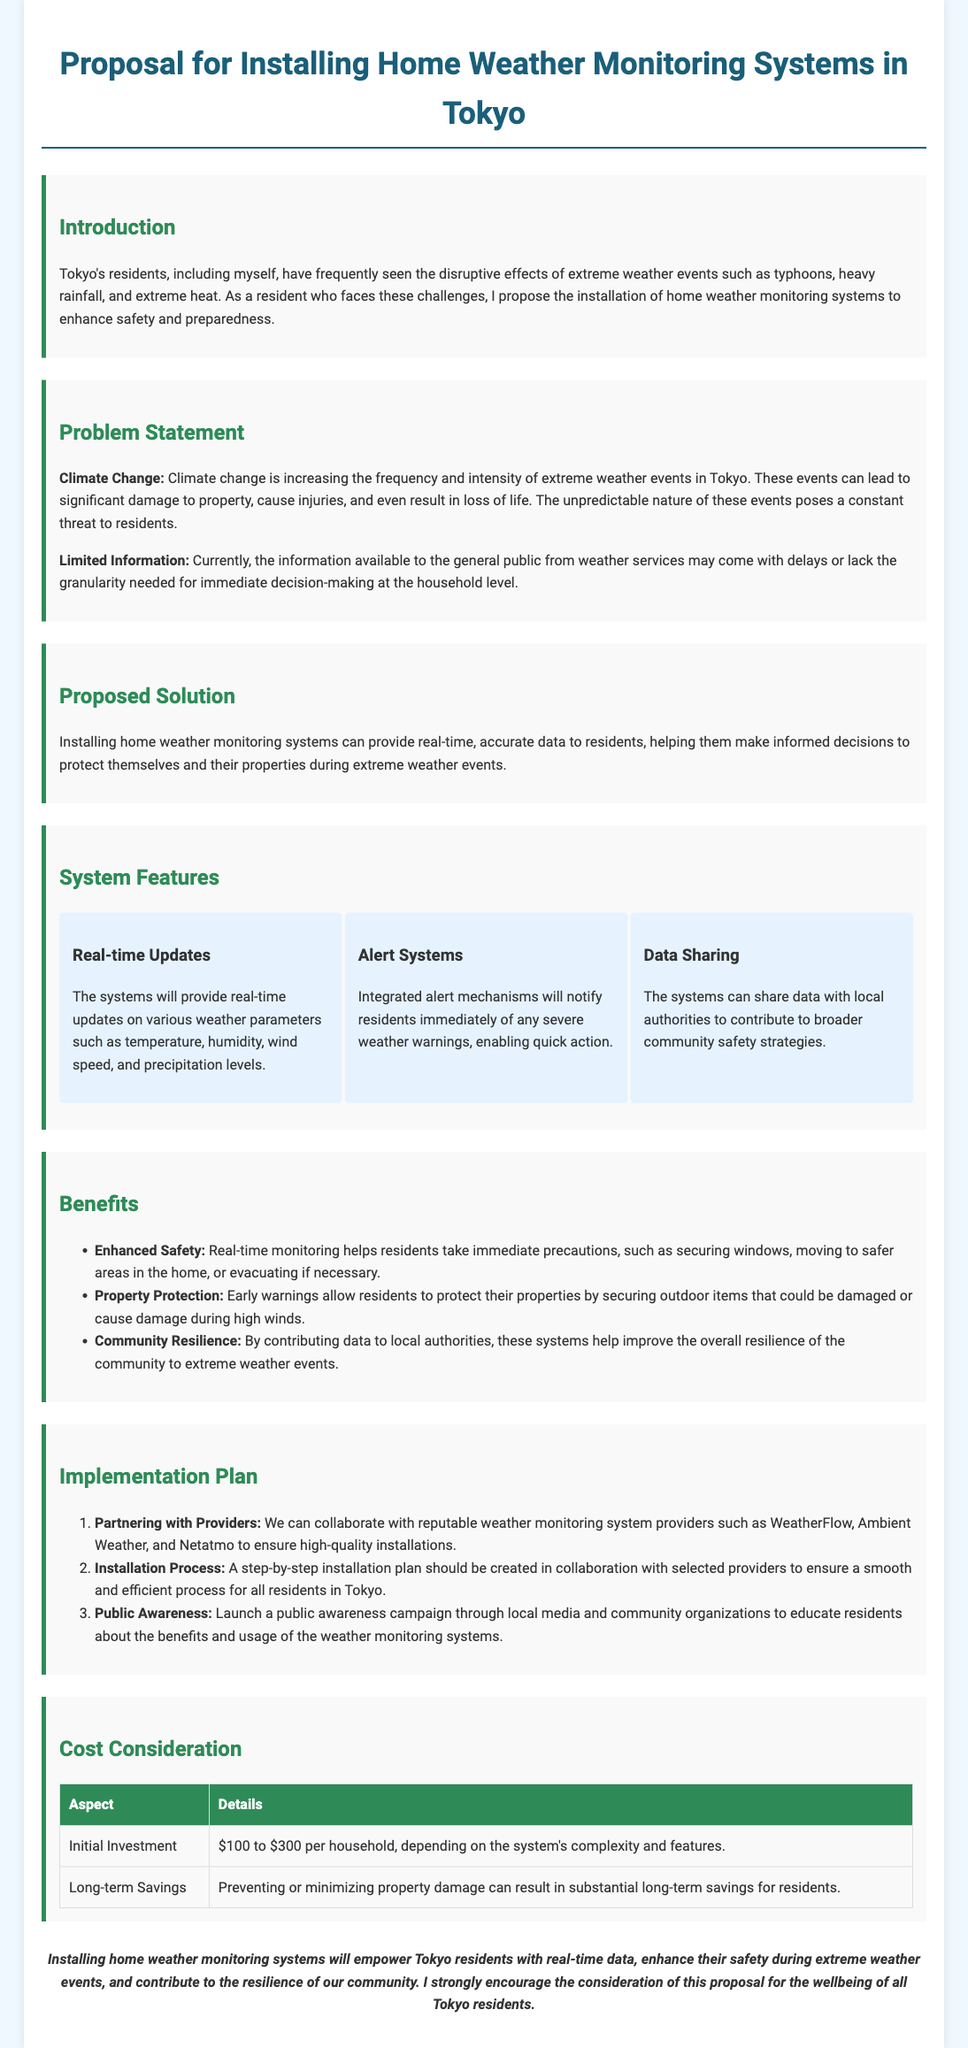What is the initial investment range for the weather monitoring systems? The document states the initial investment is between $100 and $300 per household.
Answer: $100 to $300 What problem does climate change pose for Tokyo residents? The proposal mentions that climate change is increasing the frequency and intensity of extreme weather events.
Answer: Increased frequency and intensity of extreme weather events What is one feature of the proposed weather monitoring systems? The document lists real-time updates, alert systems, and data sharing as features of the system.
Answer: Real-time Updates Which organizations are suggested for partnering in the implementation plan? The proposal suggests partnering with providers like WeatherFlow, Ambient Weather, and Netatmo.
Answer: WeatherFlow, Ambient Weather, and Netatmo What is one benefit of the weather monitoring systems mentioned in the proposal? The document specifies enhanced safety, property protection, and community resilience as benefits.
Answer: Enhanced Safety How will the public be educated about the benefits of the systems? The proposal includes launching a public awareness campaign through local media and community organizations.
Answer: Public awareness campaign What kind of alerts will the monitoring systems provide? The systems will notify residents immediately of severe weather warnings.
Answer: Severe weather warnings What action can residents take with the information from the monitoring systems? The document states that residents can take immediate precautions based on real-time monitoring.
Answer: Immediate precautions 